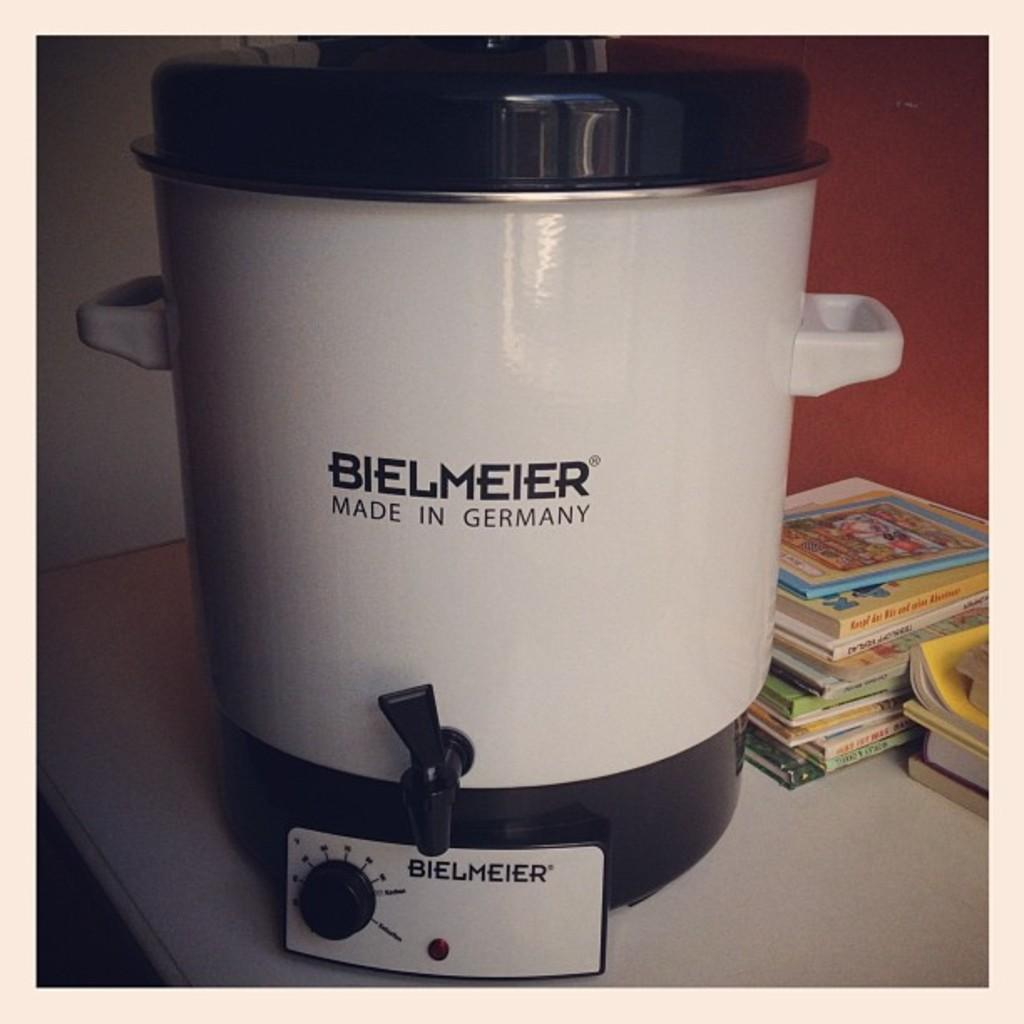<image>
Provide a brief description of the given image. A stack of books a crockpot by Bielmier. 